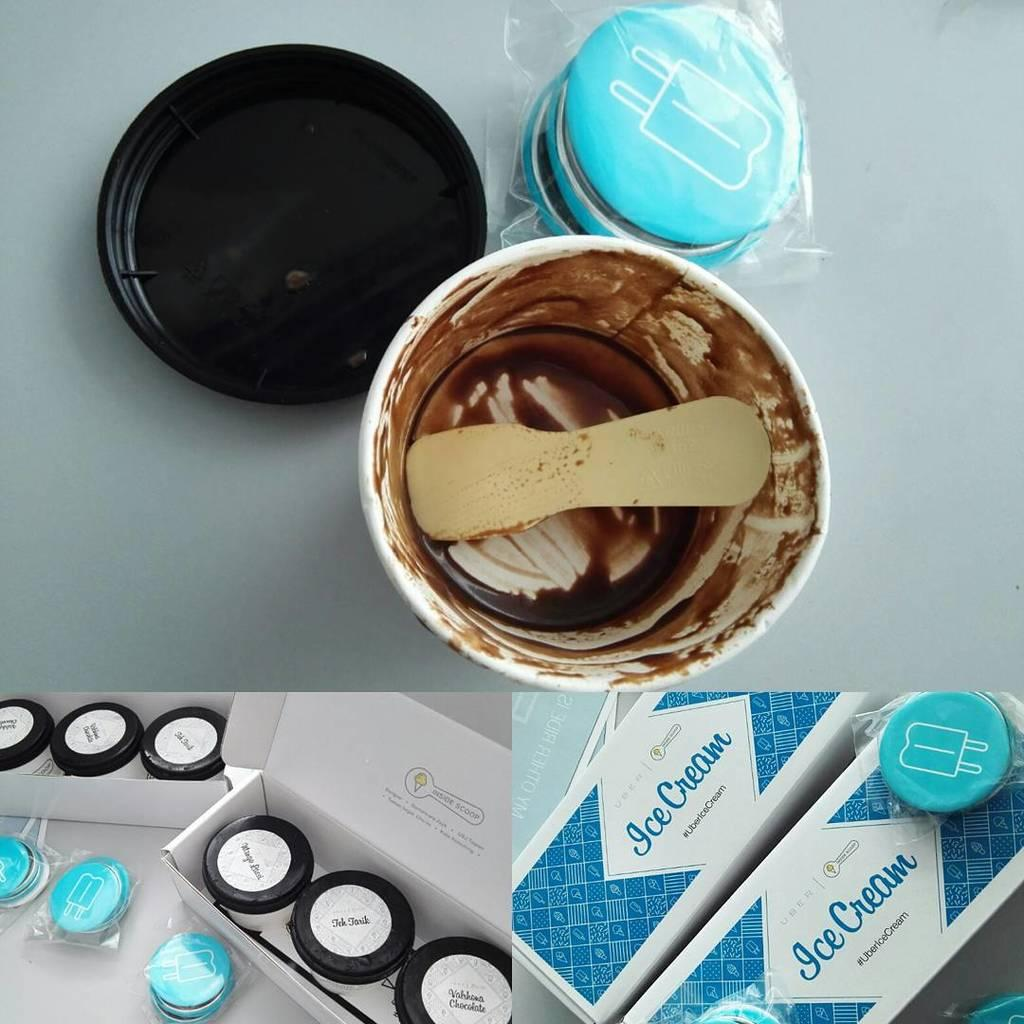<image>
Summarize the visual content of the image. Boxes of Ice Cream in small white containers with black lids and one open container of chocolate ice cream which as been eaten. 